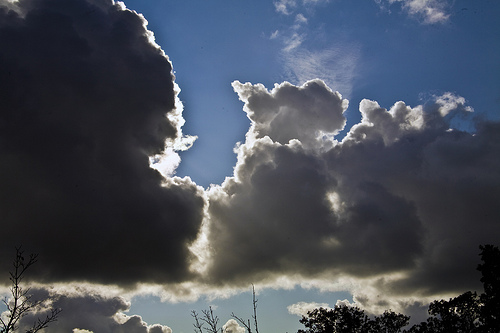<image>
Is there a light on the sky? Yes. Looking at the image, I can see the light is positioned on top of the sky, with the sky providing support. 